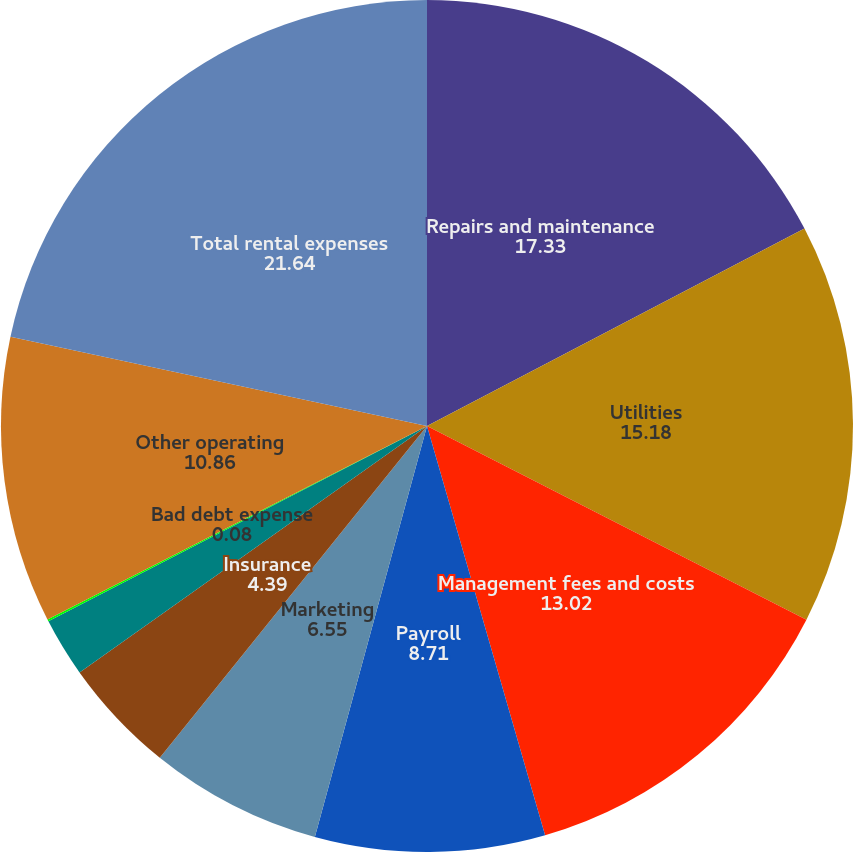Convert chart to OTSL. <chart><loc_0><loc_0><loc_500><loc_500><pie_chart><fcel>Repairs and maintenance<fcel>Utilities<fcel>Management fees and costs<fcel>Payroll<fcel>Marketing<fcel>Insurance<fcel>Ground Rent<fcel>Bad debt expense<fcel>Other operating<fcel>Total rental expenses<nl><fcel>17.33%<fcel>15.18%<fcel>13.02%<fcel>8.71%<fcel>6.55%<fcel>4.39%<fcel>2.24%<fcel>0.08%<fcel>10.86%<fcel>21.64%<nl></chart> 